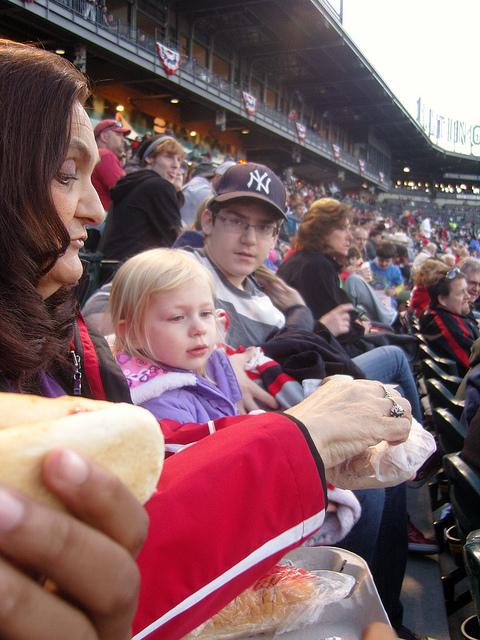What is the girl looking at?
Give a very brief answer. Food. Is the boy with the hat wearing glasses?
Answer briefly. Yes. What food item is pictured on the left of the screen?
Be succinct. Hot dog. 